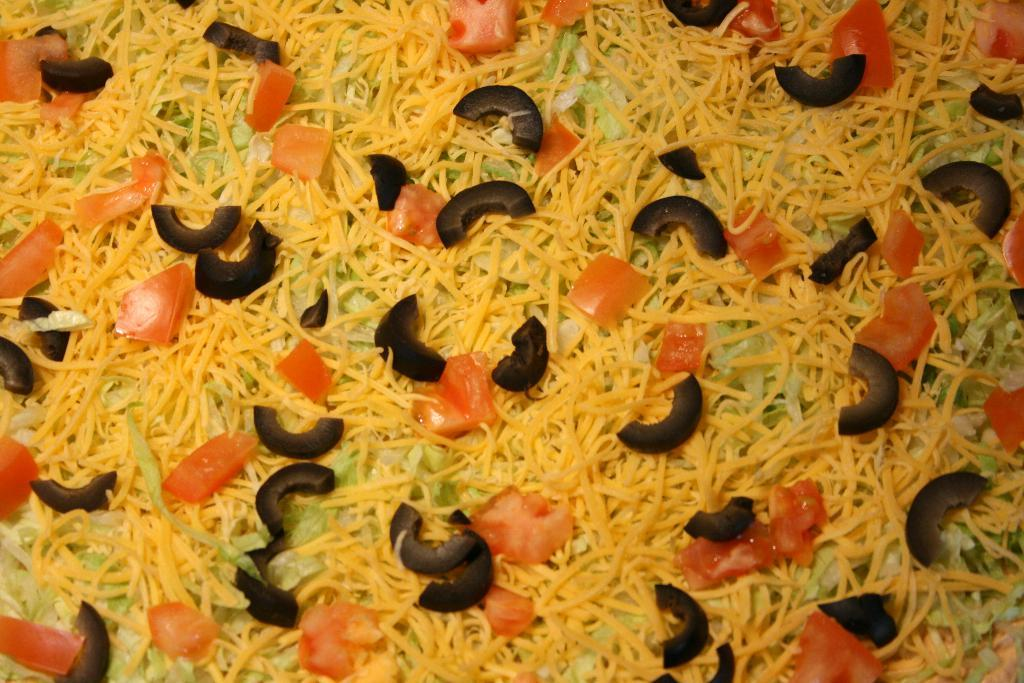What is the main subject of the image? The main subject of the image is food items. Can you identify any specific food items in the image? Yes, tomato slices are visible among the food items. Are there any other types of vegetables present in the food items? Yes, there are other vegetables present in the food items. What type of feather can be seen in the image? There is no feather present in the image; it features food items with tomato slices and other vegetables. 